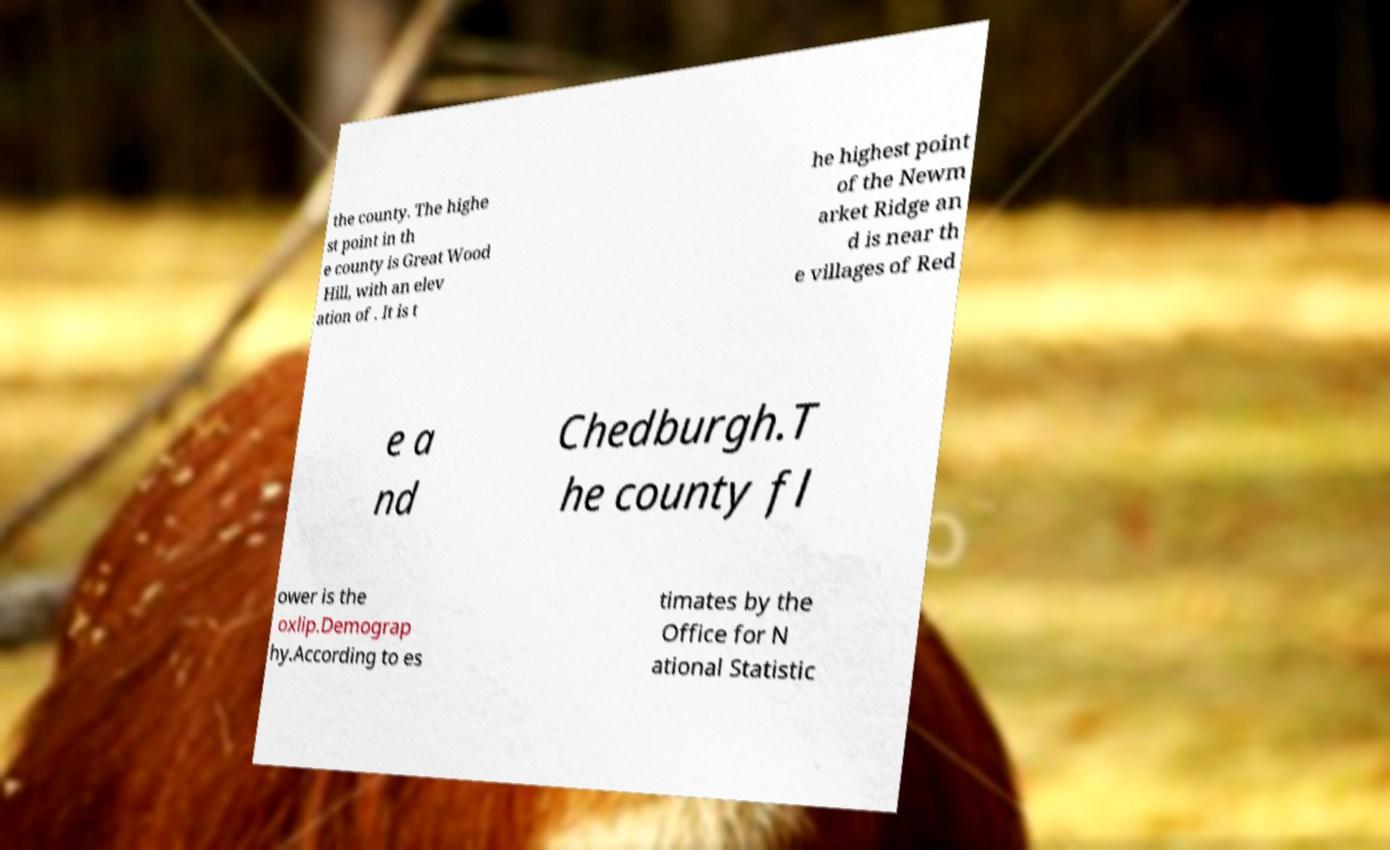For documentation purposes, I need the text within this image transcribed. Could you provide that? the county. The highe st point in th e county is Great Wood Hill, with an elev ation of . It is t he highest point of the Newm arket Ridge an d is near th e villages of Red e a nd Chedburgh.T he county fl ower is the oxlip.Demograp hy.According to es timates by the Office for N ational Statistic 